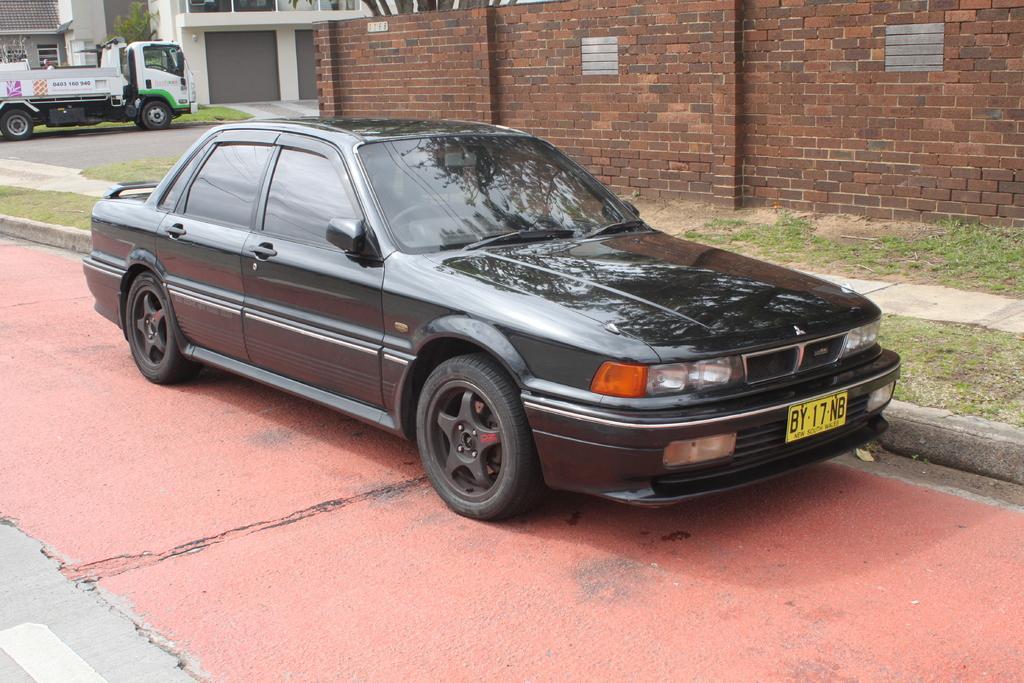How would you summarize this image in a sentence or two? In this image we can see the vehicles, grass, path, road, brick wall, trees and also the buildings. 